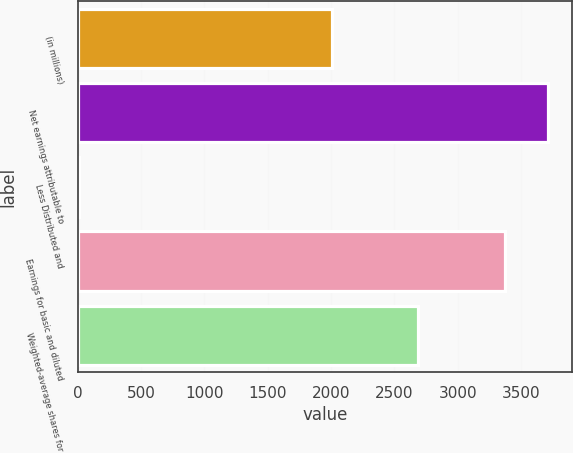<chart> <loc_0><loc_0><loc_500><loc_500><bar_chart><fcel>(in millions)<fcel>Net earnings attributable to<fcel>Less Distributed and<fcel>Earnings for basic and diluted<fcel>Weighted-average shares for<nl><fcel>2011<fcel>3714.7<fcel>13<fcel>3377<fcel>2686.4<nl></chart> 